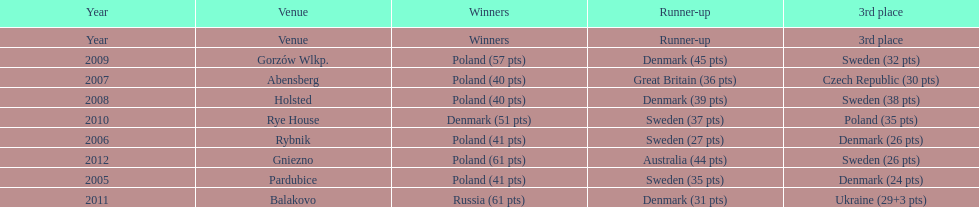I'm looking to parse the entire table for insights. Could you assist me with that? {'header': ['Year', 'Venue', 'Winners', 'Runner-up', '3rd place'], 'rows': [['Year', 'Venue', 'Winners', 'Runner-up', '3rd place'], ['2009', 'Gorzów Wlkp.', 'Poland (57 pts)', 'Denmark (45 pts)', 'Sweden (32 pts)'], ['2007', 'Abensberg', 'Poland (40 pts)', 'Great Britain (36 pts)', 'Czech Republic (30 pts)'], ['2008', 'Holsted', 'Poland (40 pts)', 'Denmark (39 pts)', 'Sweden (38 pts)'], ['2010', 'Rye House', 'Denmark (51 pts)', 'Sweden (37 pts)', 'Poland (35 pts)'], ['2006', 'Rybnik', 'Poland (41 pts)', 'Sweden (27 pts)', 'Denmark (26 pts)'], ['2012', 'Gniezno', 'Poland (61 pts)', 'Australia (44 pts)', 'Sweden (26 pts)'], ['2005', 'Pardubice', 'Poland (41 pts)', 'Sweden (35 pts)', 'Denmark (24 pts)'], ['2011', 'Balakovo', 'Russia (61 pts)', 'Denmark (31 pts)', 'Ukraine (29+3 pts)']]} Which team has the most third place wins in the speedway junior world championship between 2005 and 2012? Sweden. 